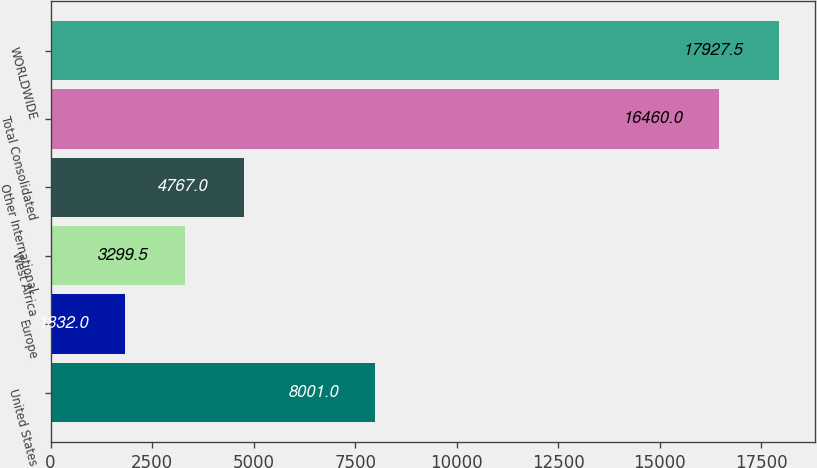Convert chart to OTSL. <chart><loc_0><loc_0><loc_500><loc_500><bar_chart><fcel>United States<fcel>Europe<fcel>West Africa<fcel>Other International<fcel>Total Consolidated<fcel>WORLDWIDE<nl><fcel>8001<fcel>1832<fcel>3299.5<fcel>4767<fcel>16460<fcel>17927.5<nl></chart> 